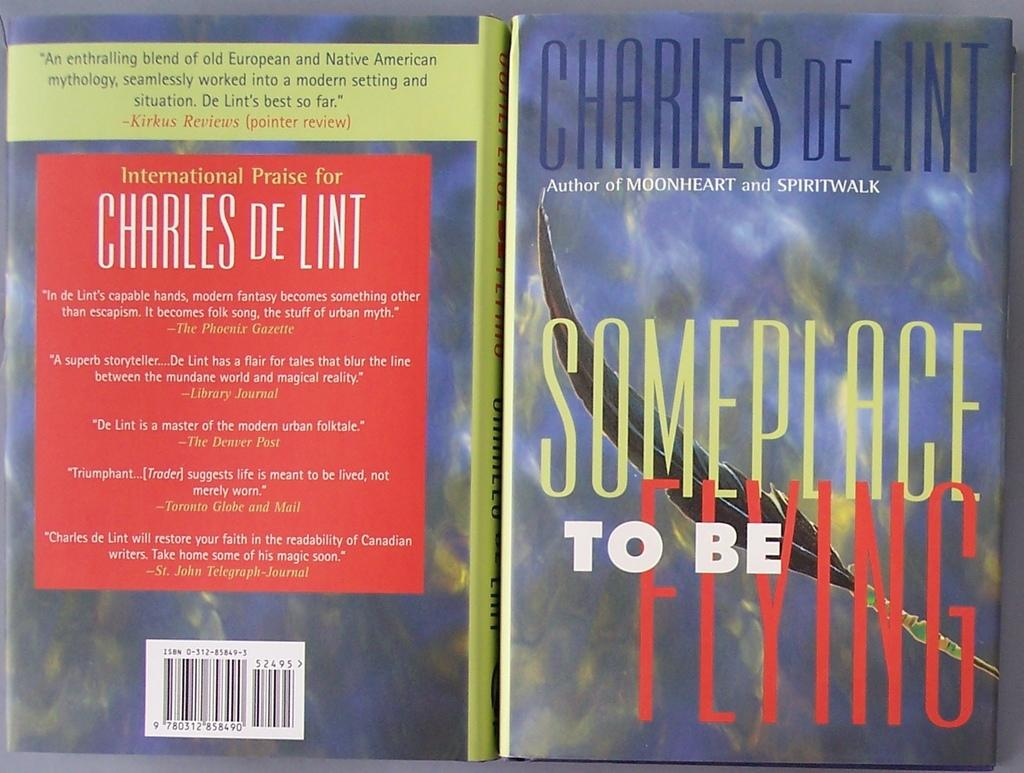<image>
Provide a brief description of the given image. A book titled Someplace to Be Flying is by Charles DeLint, who also wrote Moonheart. 